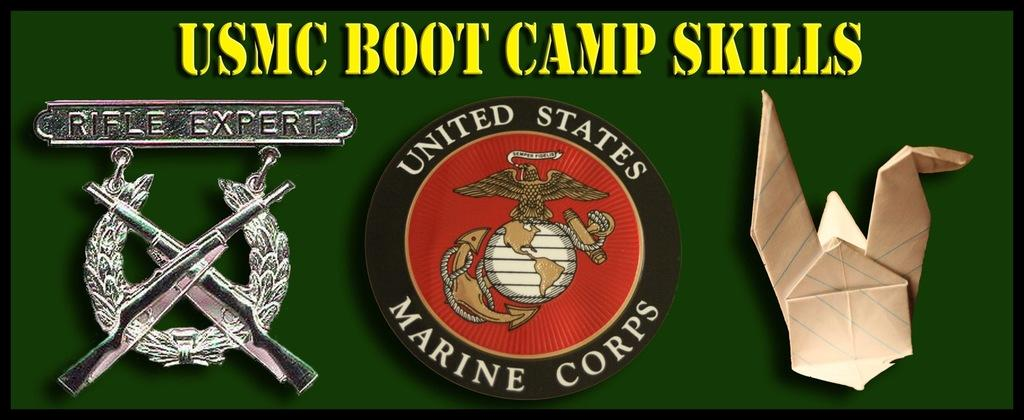How many logos can be seen in the image? There are three logos in the image. What is the background color of the logos? The logos are on a green color surface. Is there any text present in the image? Yes, there is text written on the surface. How many eggs are visible in the image? There are no eggs present in the image. Is there any soap visible in the image? There is no soap present in the image. 